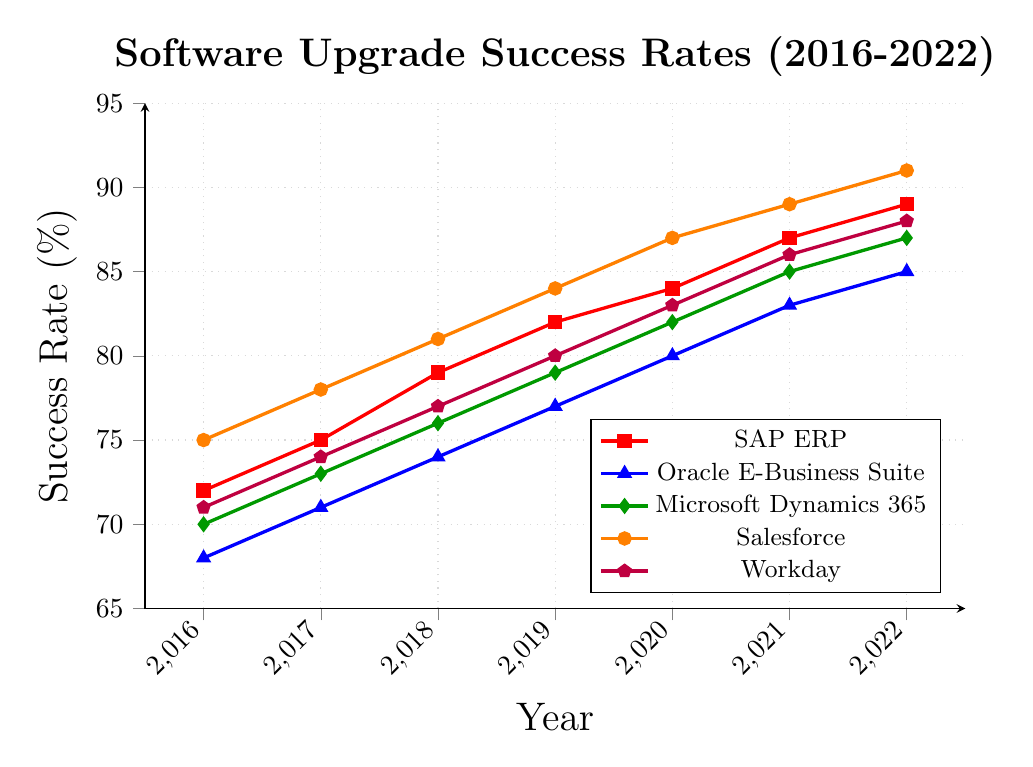What's the overall trend in success rates for SAP ERP from 2016 to 2022? The trend for SAP ERP shows a consistent increase in success rates each year from 2016 (72%) to 2022 (89%). This indicates a steady improvement over the period.
Answer: Increasing Which software had the highest success rate in 2019? In 2019, Salesforce had the highest success rate at 84%, as indicated by the highest point on the orange line for that year.
Answer: Salesforce How much did the success rate for Oracle E-Business Suite increase from 2016 to 2022? The success rate for Oracle E-Business Suite increased from 68% in 2016 to 85% in 2022. To find the increase, subtract the 2016 value from the 2022 value: 85% - 68% = 17%.
Answer: 17% Comparing 2020 and 2022, which software showed the smallest improvement in success rates? To determine the smallest improvement, calculate the increase in success rates for each software between 2020 and 2022, then compare these values:
- SAP ERP: 89% - 84% = 5%
- Oracle E-Business Suite: 85% - 80% = 5%
- Microsoft Dynamics 365: 87% - 82% = 5%
- Salesforce: 91% - 87% = 4%
- Workday: 88% - 83% = 5%
Salesforce shows the smallest improvement, with an increase of 4%.
Answer: Salesforce What is the average success rate of Microsoft Dynamics 365 across all years presented? Add up the success rates for Microsoft Dynamics 365 across the years and divide by the number of years:
(70% + 73% + 76% + 79% + 82% + 85% + 87%) / 7 = 552% / 7 = 78.86%.
Answer: 78.86% Which software has consistently shown the second-highest success rate year-over-year? Checking the success rates of each software year-over-year, Salesforce consistently ranks highest or among the highest values, and SAP ERP is the next highest after Salesforce most of the years.
Answer: SAP ERP In which year did Workday surpass the 80% success rate mark? To find this, look at Workday's success rates over the years:
- 2016: 71%
- 2017: 74%
- 2018: 77%
- 2019: 80%
- 2020: 83%
Workday surpassed the 80% mark in 2020.
Answer: 2020 What can we infer about the trend in success rates for Salesforce compared to Microsoft Dynamics 365 from 2016 to 2022? Salesforce's success rate consistently demonstrates a sharper increase compared to Microsoft Dynamics 365 over the same period. This is observed by the steeper slope of Salesforce's orange line relative to the green line for Microsoft Dynamics 365.
Answer: Salesforce shows a sharper increase How did the success rates change for all systems between 2021 and 2022? List any differences. Calculate the changes by subtracting the 2021 values from the 2022 values for each system:
- SAP ERP: 89% - 87% = 2%
- Oracle E-Business Suite: 85% - 83% = 2%
- Microsoft Dynamics 365: 87% - 85% = 2%
- Salesforce: 91% - 89% = 2%
- Workday: 88% - 86% = 2%
All systems increased by 2% between 2021 and 2022.
Answer: 2% increase for all systems 